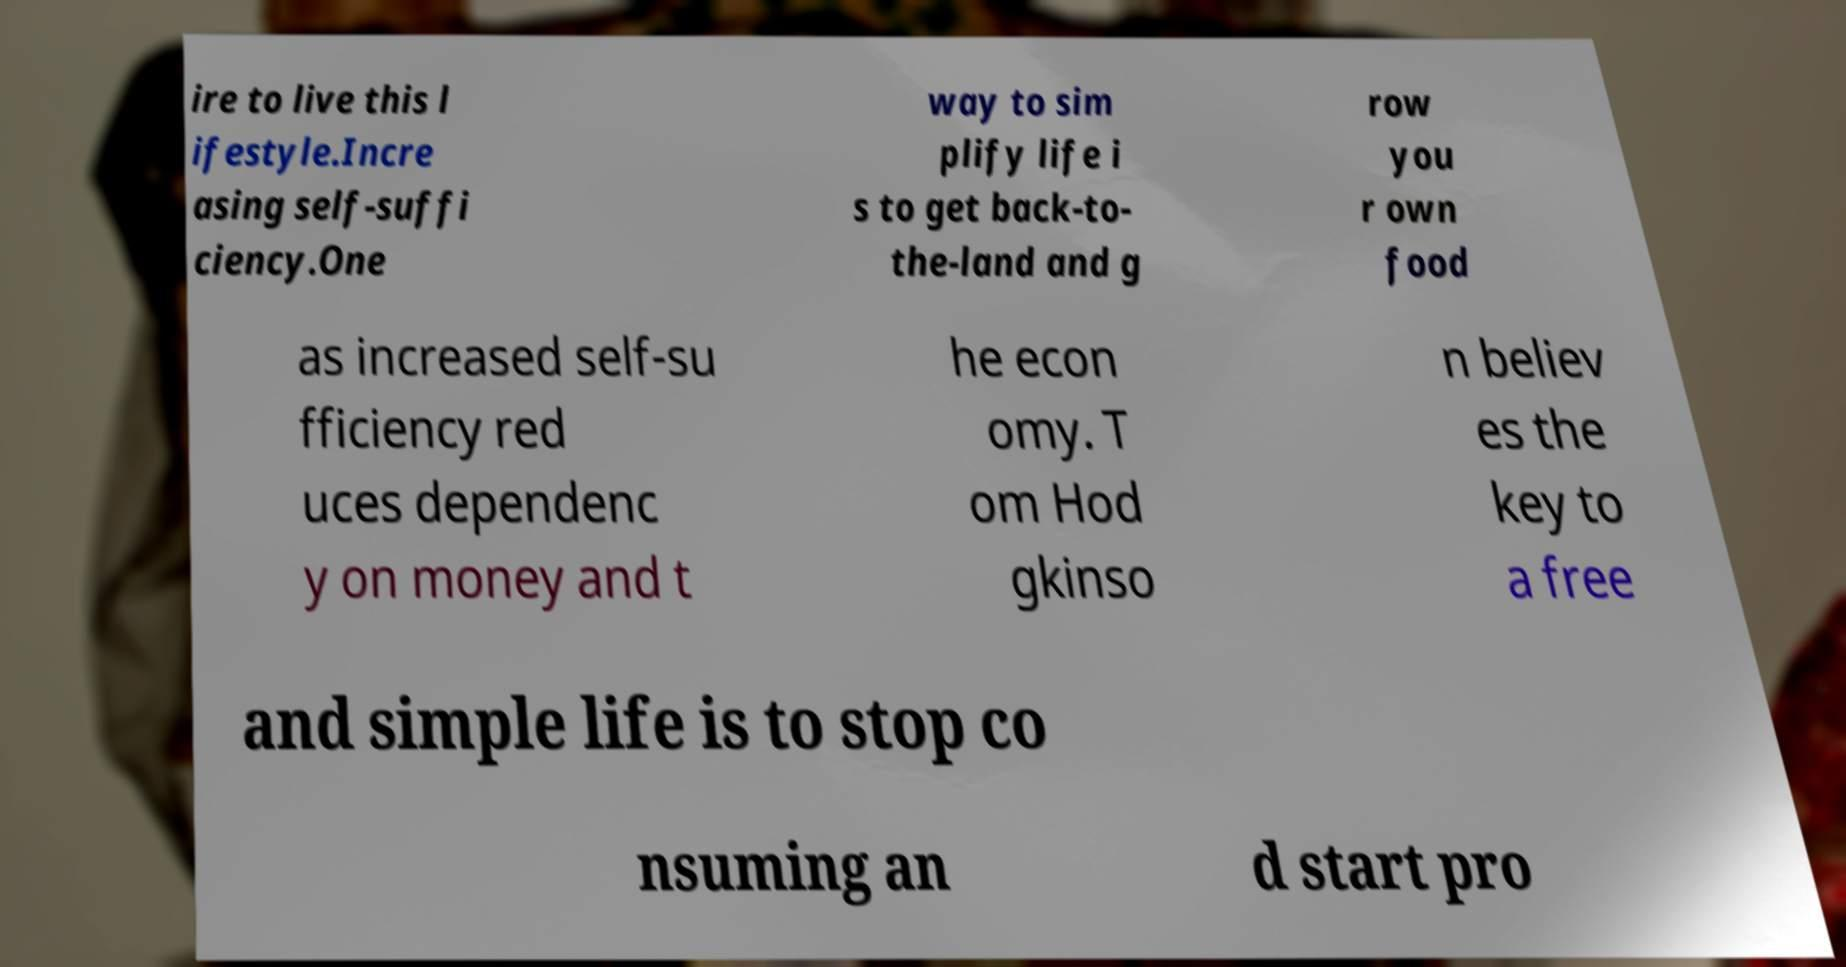I need the written content from this picture converted into text. Can you do that? ire to live this l ifestyle.Incre asing self-suffi ciency.One way to sim plify life i s to get back-to- the-land and g row you r own food as increased self-su fficiency red uces dependenc y on money and t he econ omy. T om Hod gkinso n believ es the key to a free and simple life is to stop co nsuming an d start pro 